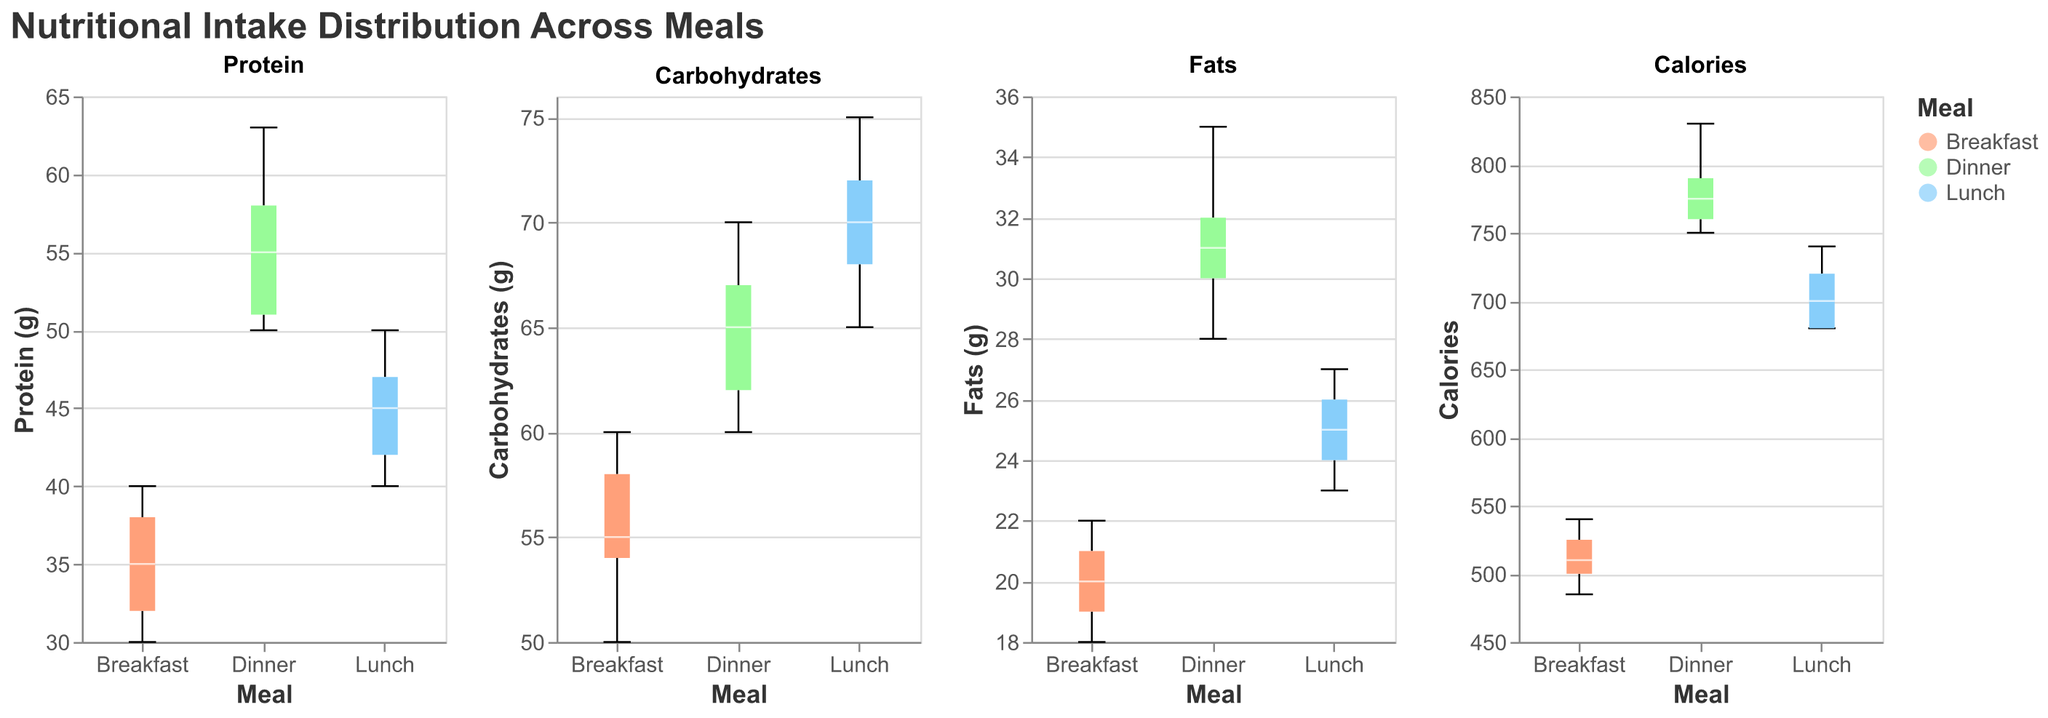What is the median protein intake for lunch? The box plot for protein intake shows the white line, indicating the median value for lunch.
Answer: 45 grams Which meal has the highest median carbohydrate intake? By comparing the box plots of carbohydrates for each meal, the highest median line is for lunch.
Answer: Lunch What is the range of fat intake during dinner? The box plot for fats during dinner shows the minimum and maximum values as the extent of the whiskers. From 28 grams to 35 grams, the range is 35 - 28.
Answer: 7 grams How do the median calorie values compare between breakfast and dinner? The white lines in the box plots for calories indicate their medians. Breakfast has a median of around 510 calories, while dinner has a median of around 760 calories. Therefore, the median calorie value for dinner is higher.
Answer: Dinner has higher median calories What is the interquartile range (IQR) for carbohydrates during breakfast? The IQR is calculated as the difference between the third quartile (Q3) and the first quartile (Q1) in the box plot. For breakfast carbohydrates, Q3 is approximately 58 grams and Q1 is approximately 54 grams. So, IQR = 58 - 54.
Answer: 4 grams Which meal exhibits the widest range of calorie intake? Examining the extent of the whiskers in each box plot for calories, dinner has a range from approximately 750 to 830 calories. It has the widest range when compared to breakfast and lunch.
Answer: Dinner From the data, which meal appears to have the highest variation in protein intake? The protein box plot with the largest interquartile range (IQR) and longest whiskers indicates the highest variation. Dinner shows the highest variation in protein intake compared to other meals.
Answer: Dinner How many meals have data points that fall outside the interquartile range for fats? Outlier data points are plotted outside the whiskers of the box plots. There are outlier points visible for all three meals (breakfast, lunch, and dinner).
Answer: Three meals What is the median value of protein intake for breakfast? The box plot for protein shows the white median line for breakfast.
Answer: 35 grams What median value indicates the meal with the smallest interquartile range for fat intake? By observing the box plots, breakfast fat intake has the smallest IQR. The median value for breakfast fat intake is around 20 grams.
Answer: 20 grams 